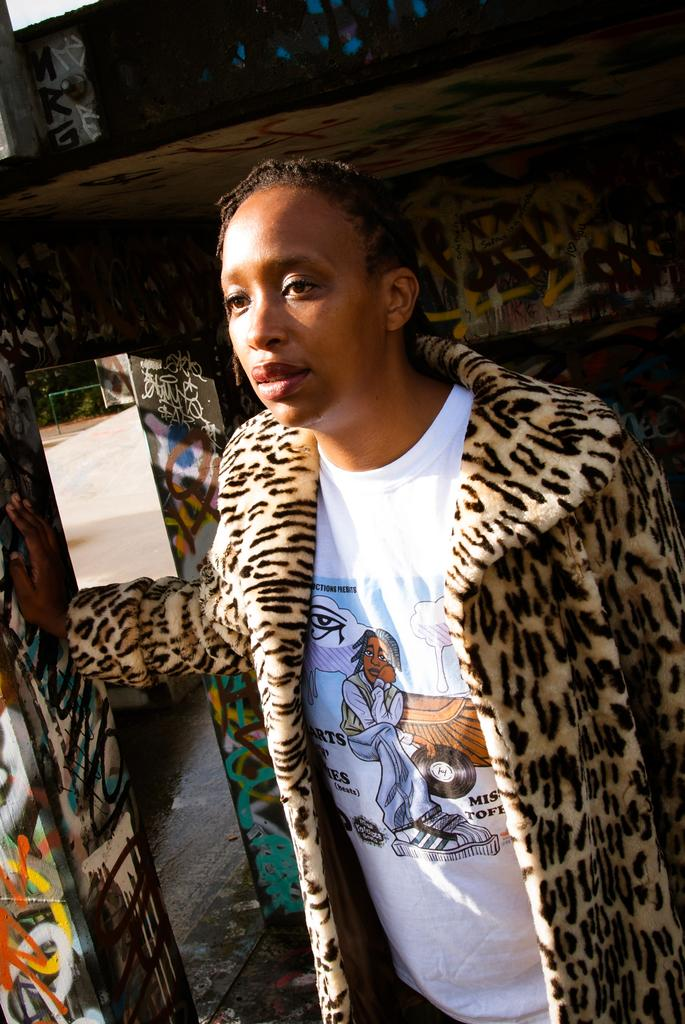Who or what is present in the image? There is a person in the image. Can you describe the surroundings or background of the image? There are objects in the background of the image. What type of flower is being carried by the person on their journey in the image? There is no flower or journey depicted in the image; it only shows a person and objects in the background. 